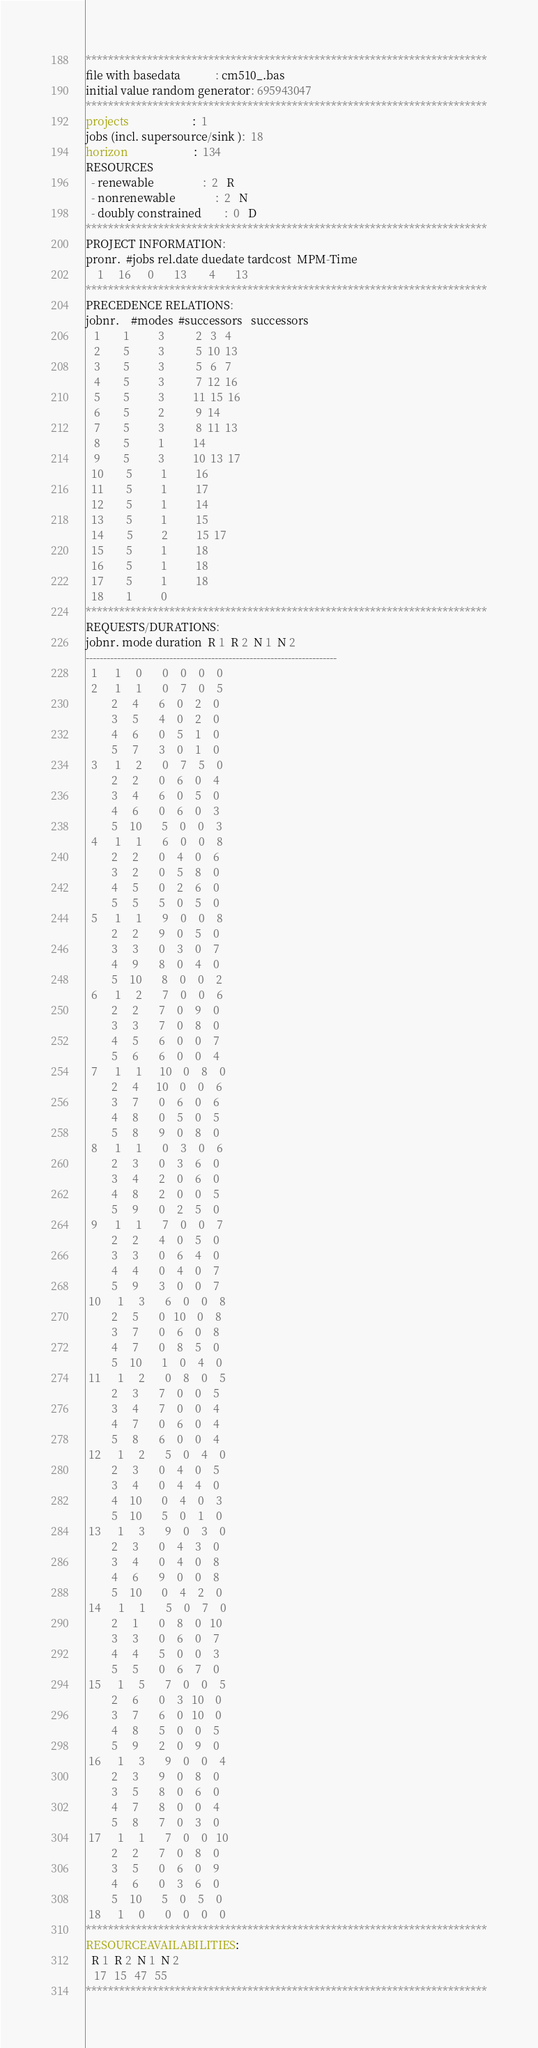Convert code to text. <code><loc_0><loc_0><loc_500><loc_500><_ObjectiveC_>************************************************************************
file with basedata            : cm510_.bas
initial value random generator: 695943047
************************************************************************
projects                      :  1
jobs (incl. supersource/sink ):  18
horizon                       :  134
RESOURCES
  - renewable                 :  2   R
  - nonrenewable              :  2   N
  - doubly constrained        :  0   D
************************************************************************
PROJECT INFORMATION:
pronr.  #jobs rel.date duedate tardcost  MPM-Time
    1     16      0       13        4       13
************************************************************************
PRECEDENCE RELATIONS:
jobnr.    #modes  #successors   successors
   1        1          3           2   3   4
   2        5          3           5  10  13
   3        5          3           5   6   7
   4        5          3           7  12  16
   5        5          3          11  15  16
   6        5          2           9  14
   7        5          3           8  11  13
   8        5          1          14
   9        5          3          10  13  17
  10        5          1          16
  11        5          1          17
  12        5          1          14
  13        5          1          15
  14        5          2          15  17
  15        5          1          18
  16        5          1          18
  17        5          1          18
  18        1          0        
************************************************************************
REQUESTS/DURATIONS:
jobnr. mode duration  R 1  R 2  N 1  N 2
------------------------------------------------------------------------
  1      1     0       0    0    0    0
  2      1     1       0    7    0    5
         2     4       6    0    2    0
         3     5       4    0    2    0
         4     6       0    5    1    0
         5     7       3    0    1    0
  3      1     2       0    7    5    0
         2     2       0    6    0    4
         3     4       6    0    5    0
         4     6       0    6    0    3
         5    10       5    0    0    3
  4      1     1       6    0    0    8
         2     2       0    4    0    6
         3     2       0    5    8    0
         4     5       0    2    6    0
         5     5       5    0    5    0
  5      1     1       9    0    0    8
         2     2       9    0    5    0
         3     3       0    3    0    7
         4     9       8    0    4    0
         5    10       8    0    0    2
  6      1     2       7    0    0    6
         2     2       7    0    9    0
         3     3       7    0    8    0
         4     5       6    0    0    7
         5     6       6    0    0    4
  7      1     1      10    0    8    0
         2     4      10    0    0    6
         3     7       0    6    0    6
         4     8       0    5    0    5
         5     8       9    0    8    0
  8      1     1       0    3    0    6
         2     3       0    3    6    0
         3     4       2    0    6    0
         4     8       2    0    0    5
         5     9       0    2    5    0
  9      1     1       7    0    0    7
         2     2       4    0    5    0
         3     3       0    6    4    0
         4     4       0    4    0    7
         5     9       3    0    0    7
 10      1     3       6    0    0    8
         2     5       0   10    0    8
         3     7       0    6    0    8
         4     7       0    8    5    0
         5    10       1    0    4    0
 11      1     2       0    8    0    5
         2     3       7    0    0    5
         3     4       7    0    0    4
         4     7       0    6    0    4
         5     8       6    0    0    4
 12      1     2       5    0    4    0
         2     3       0    4    0    5
         3     4       0    4    4    0
         4    10       0    4    0    3
         5    10       5    0    1    0
 13      1     3       9    0    3    0
         2     3       0    4    3    0
         3     4       0    4    0    8
         4     6       9    0    0    8
         5    10       0    4    2    0
 14      1     1       5    0    7    0
         2     1       0    8    0   10
         3     3       0    6    0    7
         4     4       5    0    0    3
         5     5       0    6    7    0
 15      1     5       7    0    0    5
         2     6       0    3   10    0
         3     7       6    0   10    0
         4     8       5    0    0    5
         5     9       2    0    9    0
 16      1     3       9    0    0    4
         2     3       9    0    8    0
         3     5       8    0    6    0
         4     7       8    0    0    4
         5     8       7    0    3    0
 17      1     1       7    0    0   10
         2     2       7    0    8    0
         3     5       0    6    0    9
         4     6       0    3    6    0
         5    10       5    0    5    0
 18      1     0       0    0    0    0
************************************************************************
RESOURCEAVAILABILITIES:
  R 1  R 2  N 1  N 2
   17   15   47   55
************************************************************************
</code> 